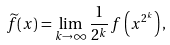Convert formula to latex. <formula><loc_0><loc_0><loc_500><loc_500>\widetilde { f } ( x ) = \lim _ { k \to \infty } \frac { 1 } { 2 ^ { k } } \, f \left ( x ^ { 2 ^ { k } } \right ) ,</formula> 